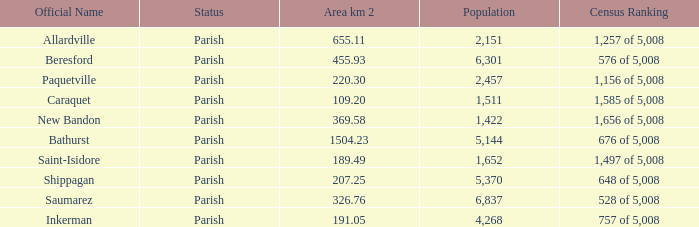What is the Area of the Allardville Parish with a Population smaller than 2,151? None. 